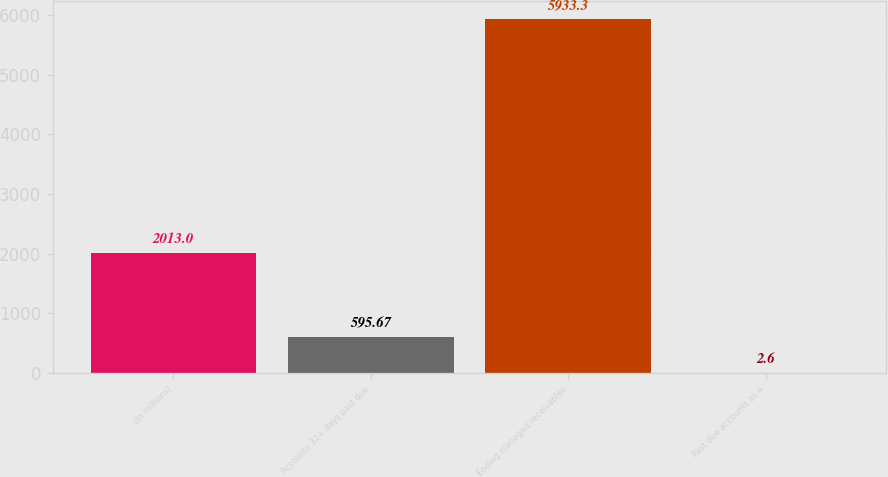Convert chart to OTSL. <chart><loc_0><loc_0><loc_500><loc_500><bar_chart><fcel>(In millions)<fcel>Accounts 31+ days past due<fcel>Ending managed receivables<fcel>Past due accounts as a<nl><fcel>2013<fcel>595.67<fcel>5933.3<fcel>2.6<nl></chart> 